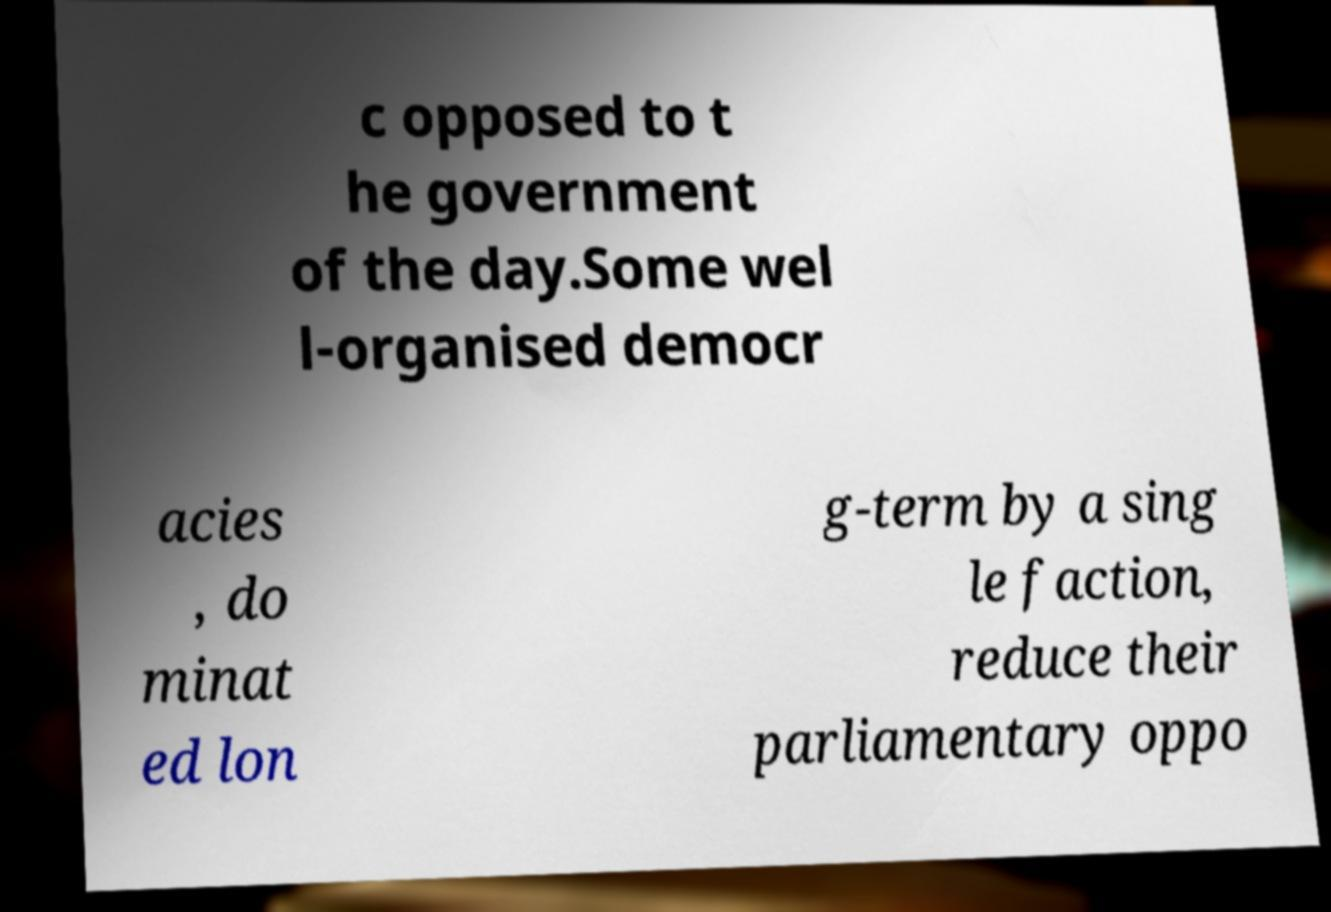Can you accurately transcribe the text from the provided image for me? c opposed to t he government of the day.Some wel l-organised democr acies , do minat ed lon g-term by a sing le faction, reduce their parliamentary oppo 